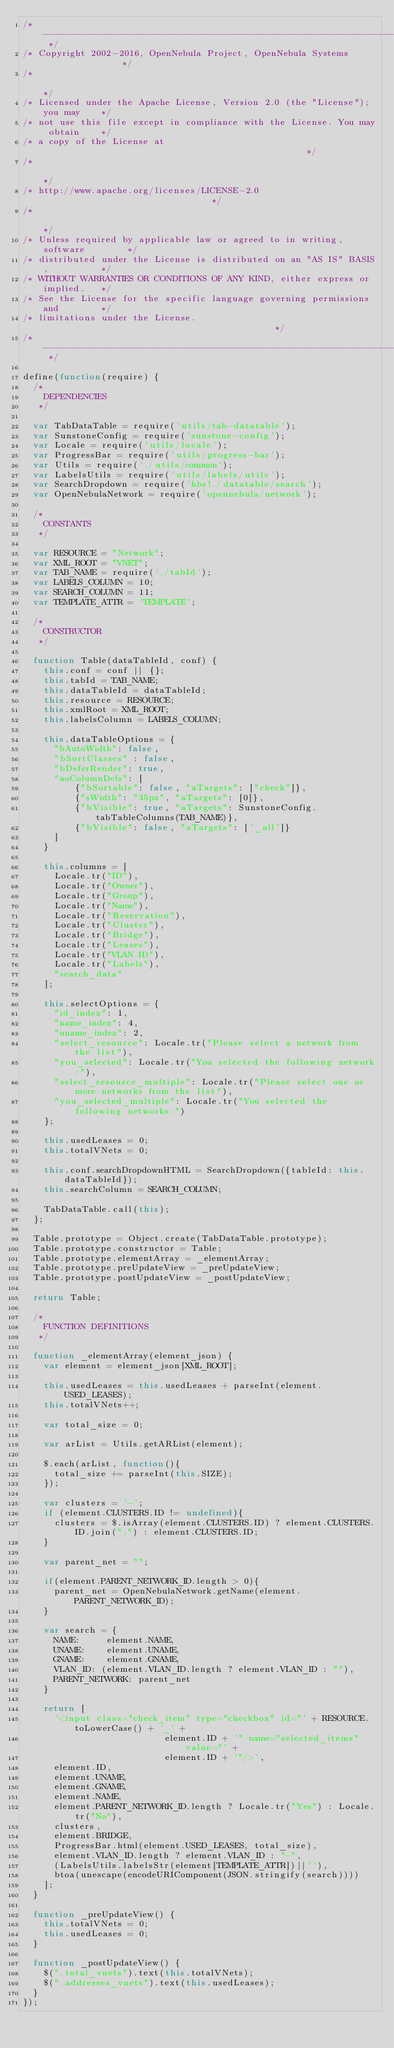<code> <loc_0><loc_0><loc_500><loc_500><_JavaScript_>/* -------------------------------------------------------------------------- */
/* Copyright 2002-2016, OpenNebula Project, OpenNebula Systems                */
/*                                                                            */
/* Licensed under the Apache License, Version 2.0 (the "License"); you may    */
/* not use this file except in compliance with the License. You may obtain    */
/* a copy of the License at                                                   */
/*                                                                            */
/* http://www.apache.org/licenses/LICENSE-2.0                                 */
/*                                                                            */
/* Unless required by applicable law or agreed to in writing, software        */
/* distributed under the License is distributed on an "AS IS" BASIS,          */
/* WITHOUT WARRANTIES OR CONDITIONS OF ANY KIND, either express or implied.   */
/* See the License for the specific language governing permissions and        */
/* limitations under the License.                                             */
/* -------------------------------------------------------------------------- */

define(function(require) {
  /*
    DEPENDENCIES
   */

  var TabDataTable = require('utils/tab-datatable');
  var SunstoneConfig = require('sunstone-config');
  var Locale = require('utils/locale');
  var ProgressBar = require('utils/progress-bar');
  var Utils = require('./utils/common');
  var LabelsUtils = require('utils/labels/utils');
  var SearchDropdown = require('hbs!./datatable/search');
  var OpenNebulaNetwork = require('opennebula/network');

  /*
    CONSTANTS
   */

  var RESOURCE = "Network";
  var XML_ROOT = "VNET";
  var TAB_NAME = require('./tabId');
  var LABELS_COLUMN = 10;
  var SEARCH_COLUMN = 11;
  var TEMPLATE_ATTR = 'TEMPLATE';

  /*
    CONSTRUCTOR
   */

  function Table(dataTableId, conf) {
    this.conf = conf || {};
    this.tabId = TAB_NAME;
    this.dataTableId = dataTableId;
    this.resource = RESOURCE;
    this.xmlRoot = XML_ROOT;
    this.labelsColumn = LABELS_COLUMN;

    this.dataTableOptions = {
      "bAutoWidth": false,
      "bSortClasses" : false,
      "bDeferRender": true,
      "aoColumnDefs": [
          {"bSortable": false, "aTargets": ["check"]},
          {"sWidth": "35px", "aTargets": [0]},
          {"bVisible": true, "aTargets": SunstoneConfig.tabTableColumns(TAB_NAME)},
          {"bVisible": false, "aTargets": ['_all']}
      ]
    }

    this.columns = [
      Locale.tr("ID"),
      Locale.tr("Owner"),
      Locale.tr("Group"),
      Locale.tr("Name"),
      Locale.tr("Reservation"),
      Locale.tr("Cluster"),
      Locale.tr("Bridge"),
      Locale.tr("Leases"),
      Locale.tr("VLAN ID"),
      Locale.tr("Labels"),
      "search_data"
    ];

    this.selectOptions = {
      "id_index": 1,
      "name_index": 4,
      "uname_index": 2,
      "select_resource": Locale.tr("Please select a network from the list"),
      "you_selected": Locale.tr("You selected the following network:"),
      "select_resource_multiple": Locale.tr("Please select one or more networks from the list"),
      "you_selected_multiple": Locale.tr("You selected the following networks:")
    };

    this.usedLeases = 0;
    this.totalVNets = 0;

    this.conf.searchDropdownHTML = SearchDropdown({tableId: this.dataTableId});
    this.searchColumn = SEARCH_COLUMN;

    TabDataTable.call(this);
  };

  Table.prototype = Object.create(TabDataTable.prototype);
  Table.prototype.constructor = Table;
  Table.prototype.elementArray = _elementArray;
  Table.prototype.preUpdateView = _preUpdateView;
  Table.prototype.postUpdateView = _postUpdateView;

  return Table;

  /*
    FUNCTION DEFINITIONS
   */

  function _elementArray(element_json) {
    var element = element_json[XML_ROOT];

    this.usedLeases = this.usedLeases + parseInt(element.USED_LEASES);
    this.totalVNets++;

    var total_size = 0;

    var arList = Utils.getARList(element);

    $.each(arList, function(){
      total_size += parseInt(this.SIZE);
    });

    var clusters = '-';
    if (element.CLUSTERS.ID != undefined){
      clusters = $.isArray(element.CLUSTERS.ID) ? element.CLUSTERS.ID.join(",") : element.CLUSTERS.ID;
    }

    var parent_net = "";

    if(element.PARENT_NETWORK_ID.length > 0){
      parent_net = OpenNebulaNetwork.getName(element.PARENT_NETWORK_ID);
    }

    var search = {
      NAME:     element.NAME,
      UNAME:    element.UNAME,
      GNAME:    element.GNAME,
      VLAN_ID: (element.VLAN_ID.length ? element.VLAN_ID : ""),
      PARENT_NETWORK: parent_net
    }

    return [
      '<input class="check_item" type="checkbox" id="' + RESOURCE.toLowerCase() + '_' +
                           element.ID + '" name="selected_items" value="' +
                           element.ID + '"/>',
      element.ID,
      element.UNAME,
      element.GNAME,
      element.NAME,
      element.PARENT_NETWORK_ID.length ? Locale.tr("Yes") : Locale.tr("No"),
      clusters,
      element.BRIDGE,
      ProgressBar.html(element.USED_LEASES, total_size),
      element.VLAN_ID.length ? element.VLAN_ID : "-",
      (LabelsUtils.labelsStr(element[TEMPLATE_ATTR])||''),
      btoa(unescape(encodeURIComponent(JSON.stringify(search))))
    ];
  }

  function _preUpdateView() {
    this.totalVNets = 0;
    this.usedLeases = 0;
  }

  function _postUpdateView() {
    $(".total_vnets").text(this.totalVNets);
    $(".addresses_vnets").text(this.usedLeases);
  }
});
</code> 